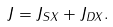<formula> <loc_0><loc_0><loc_500><loc_500>J = J _ { S X } + J _ { D X } .</formula> 